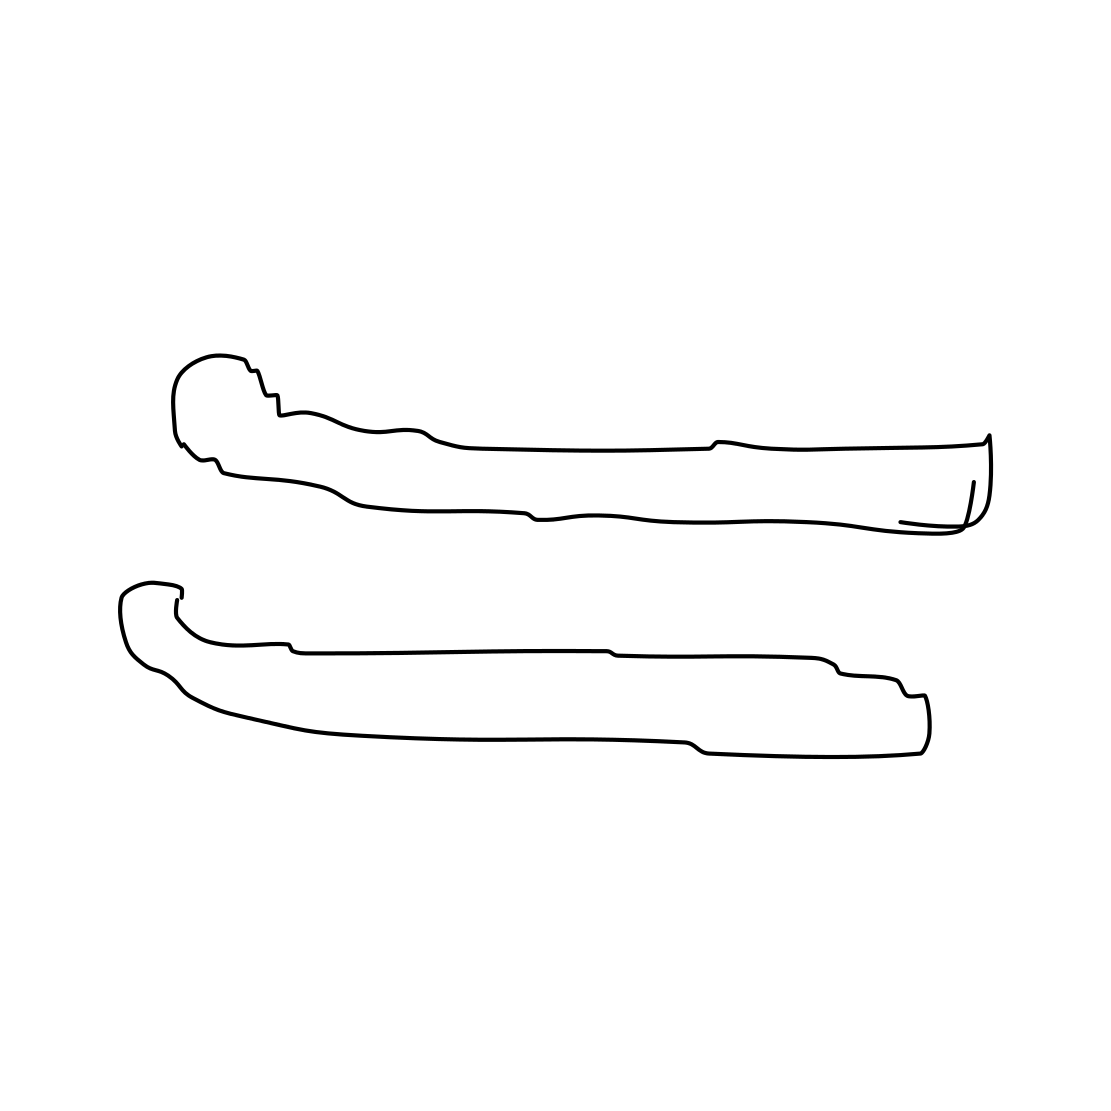In the scene, is a scissors in it? I see no scissors present in the image provided. It appears to be an illustration of two long, curved objects that could be interpreted as tongs, tools, or abstract shapes. They're lacking the pivot point that characterizes scissors. 